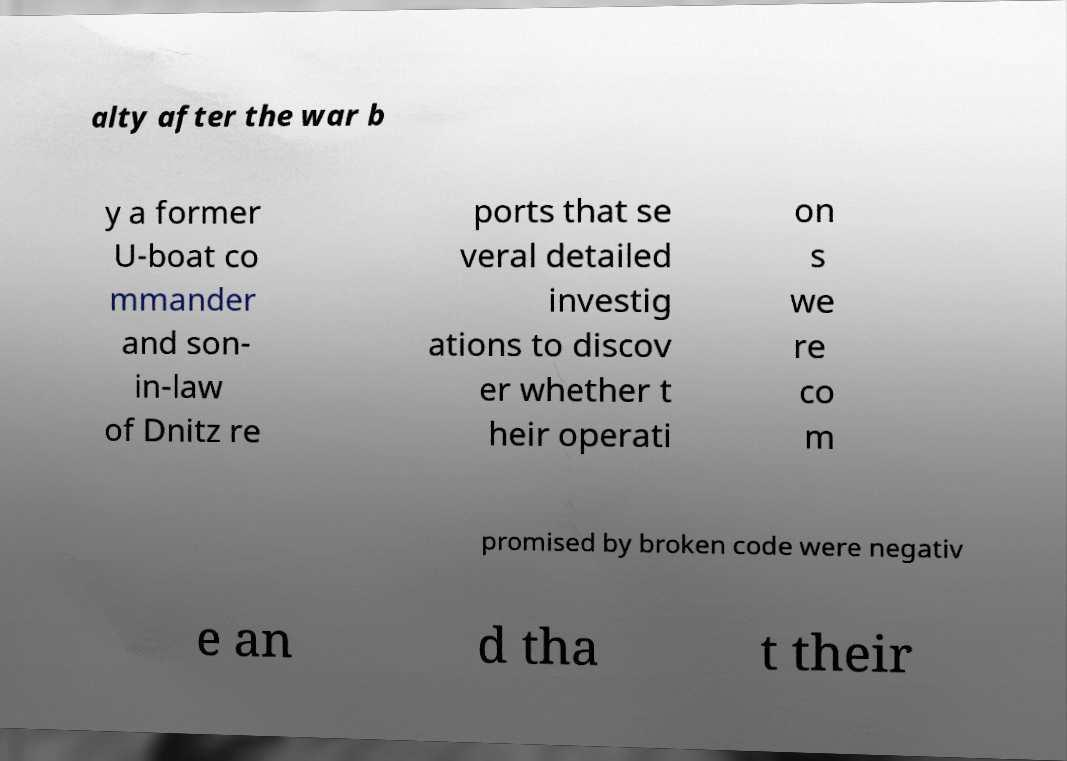Please identify and transcribe the text found in this image. alty after the war b y a former U-boat co mmander and son- in-law of Dnitz re ports that se veral detailed investig ations to discov er whether t heir operati on s we re co m promised by broken code were negativ e an d tha t their 